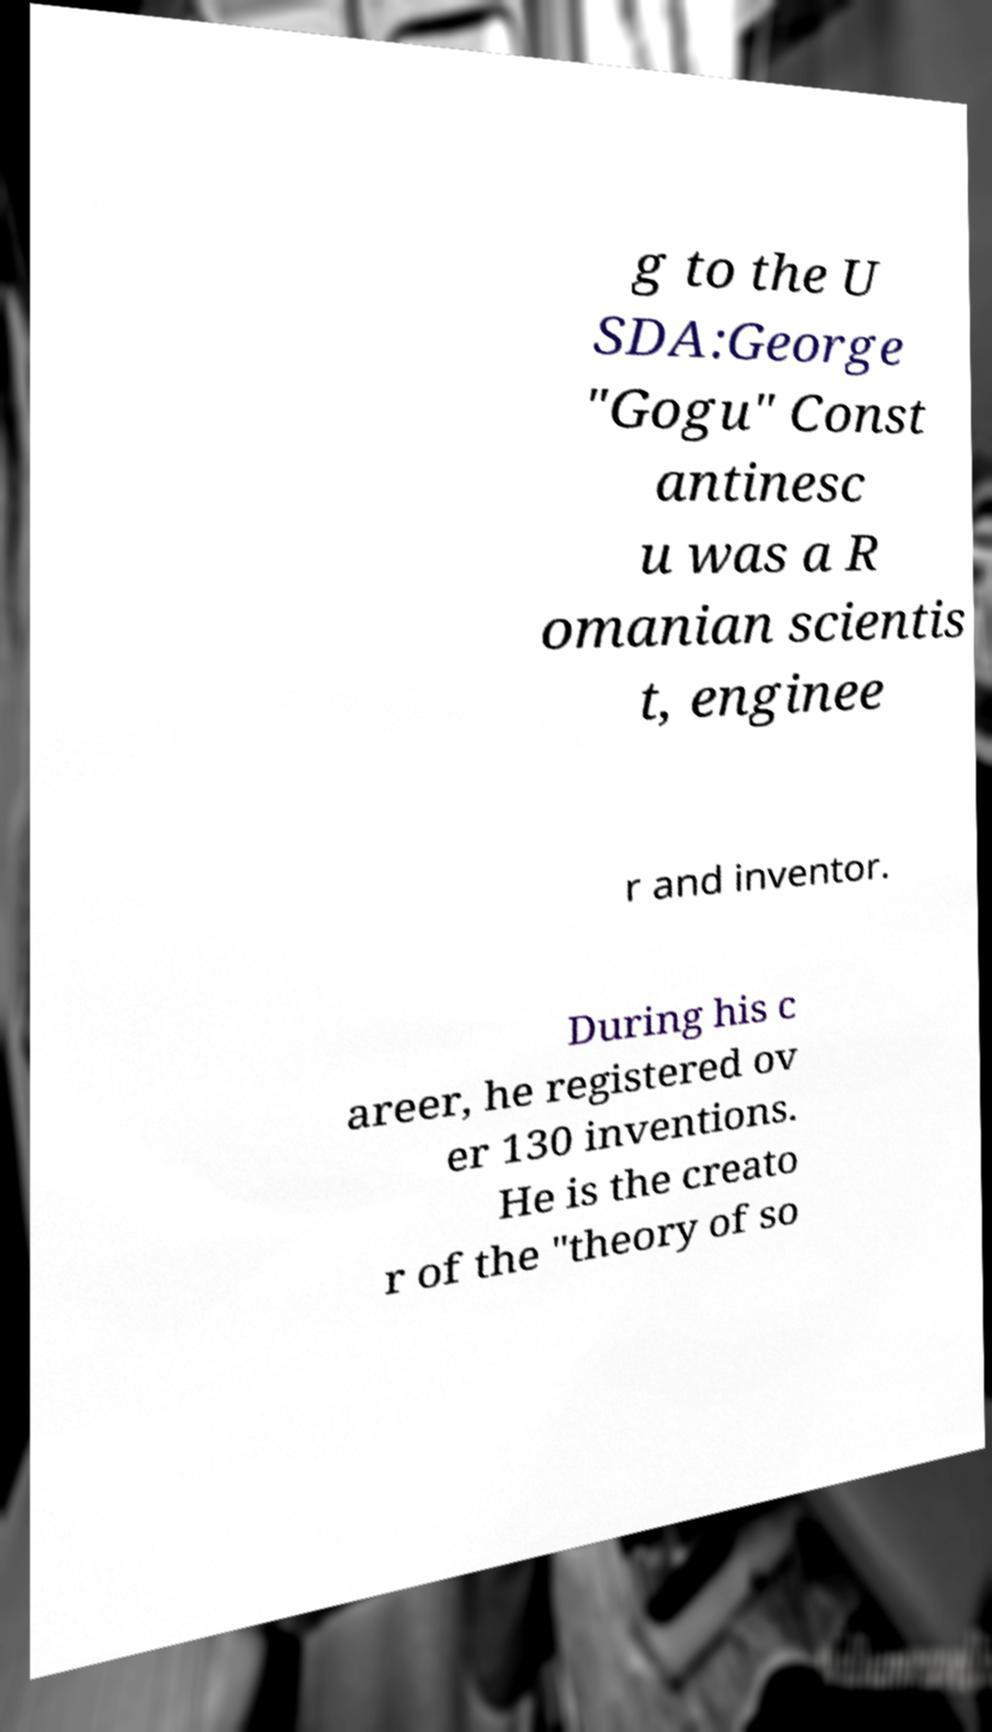Please identify and transcribe the text found in this image. g to the U SDA:George "Gogu" Const antinesc u was a R omanian scientis t, enginee r and inventor. During his c areer, he registered ov er 130 inventions. He is the creato r of the "theory of so 